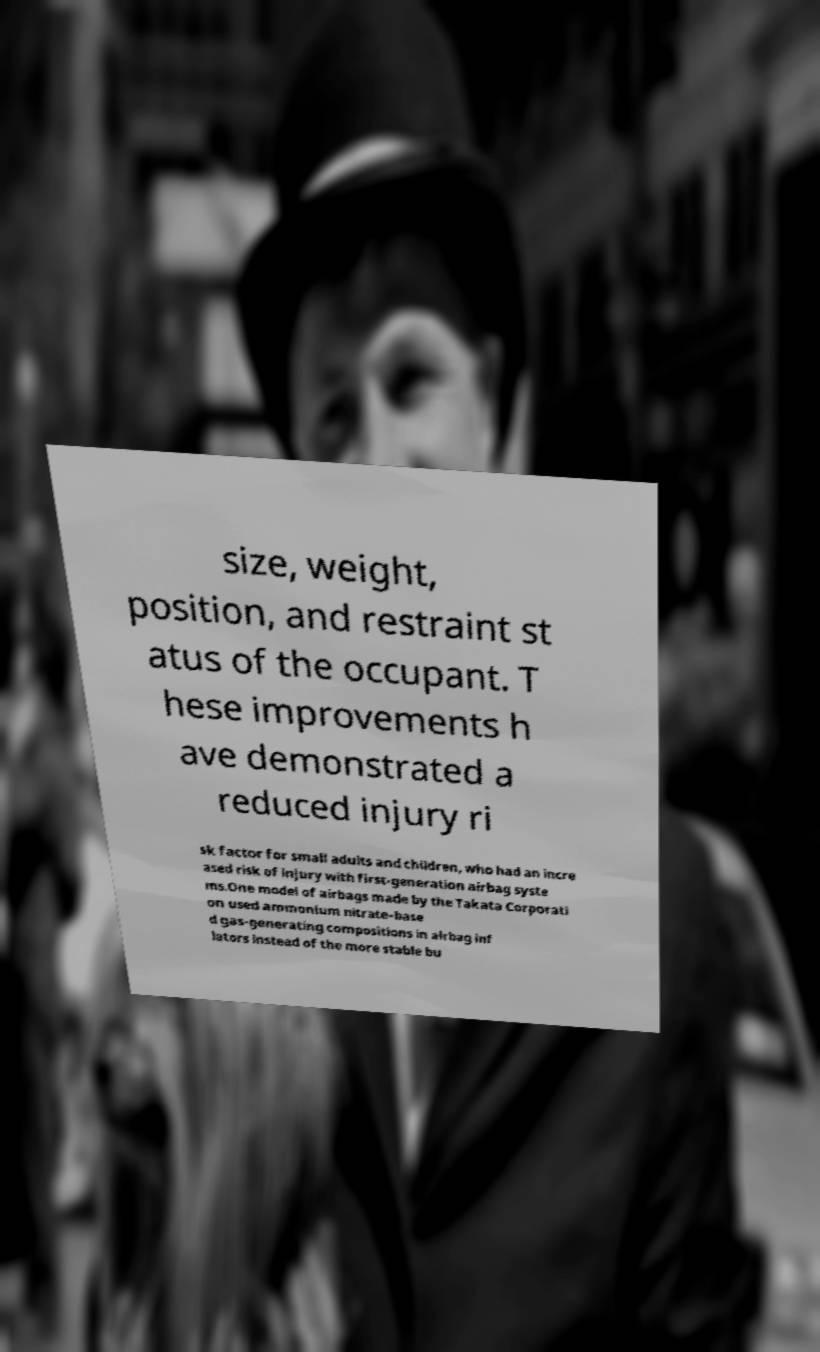Please identify and transcribe the text found in this image. size, weight, position, and restraint st atus of the occupant. T hese improvements h ave demonstrated a reduced injury ri sk factor for small adults and children, who had an incre ased risk of injury with first-generation airbag syste ms.One model of airbags made by the Takata Corporati on used ammonium nitrate–base d gas-generating compositions in airbag inf lators instead of the more stable bu 